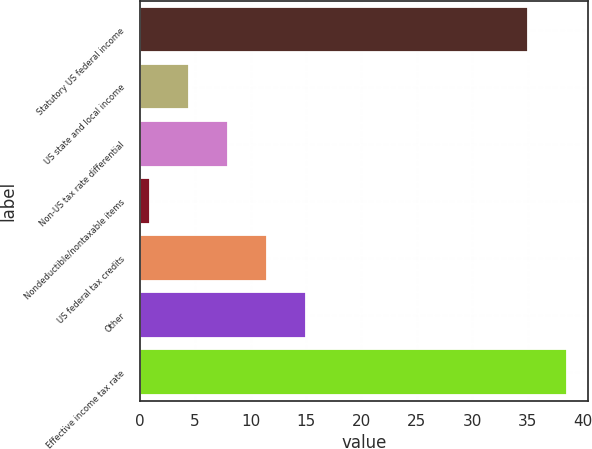Convert chart. <chart><loc_0><loc_0><loc_500><loc_500><bar_chart><fcel>Statutory US federal income<fcel>US state and local income<fcel>Non-US tax rate differential<fcel>Nondeductible/nontaxable items<fcel>US federal tax credits<fcel>Other<fcel>Effective income tax rate<nl><fcel>35<fcel>4.42<fcel>7.94<fcel>0.9<fcel>11.46<fcel>14.98<fcel>38.52<nl></chart> 